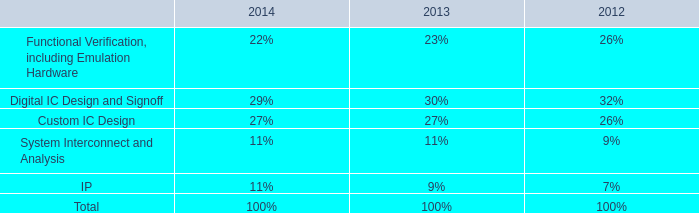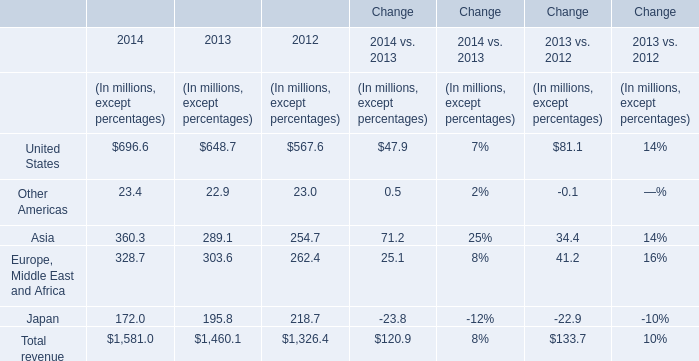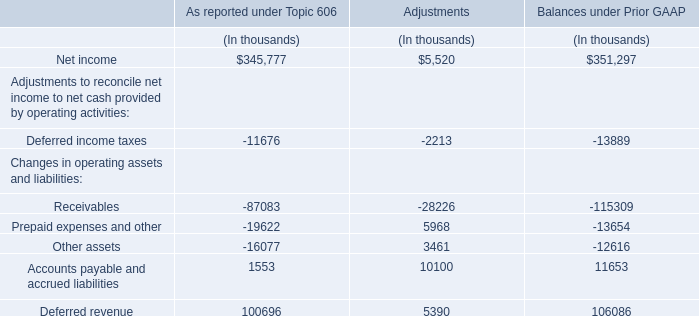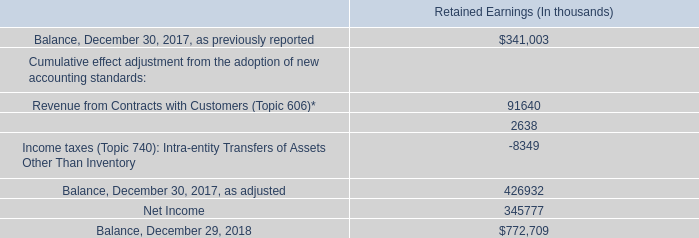What's the greatest value of United States in 2013? (in millions) 
Answer: 648.7. 